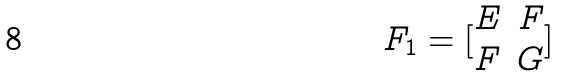Convert formula to latex. <formula><loc_0><loc_0><loc_500><loc_500>F _ { 1 } = [ \begin{matrix} E & F \\ F & G \end{matrix} ]</formula> 